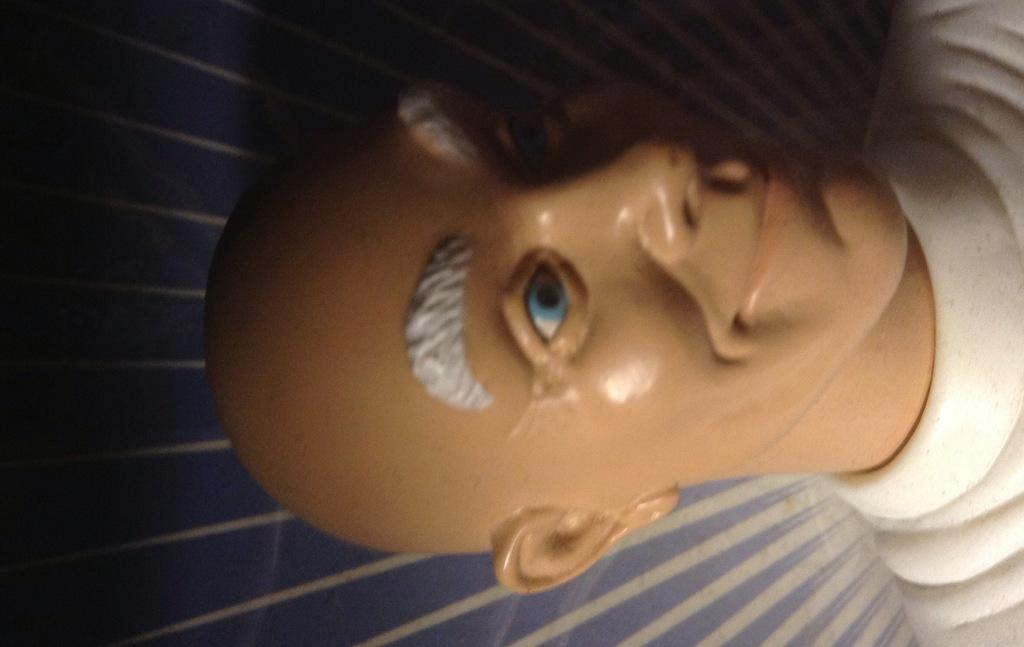What is the main subject of the image? There is a mannequin in the image. What type of trick does the mannequin perform in the image? There is no trick being performed by the mannequin in the image, as it is an inanimate object. 